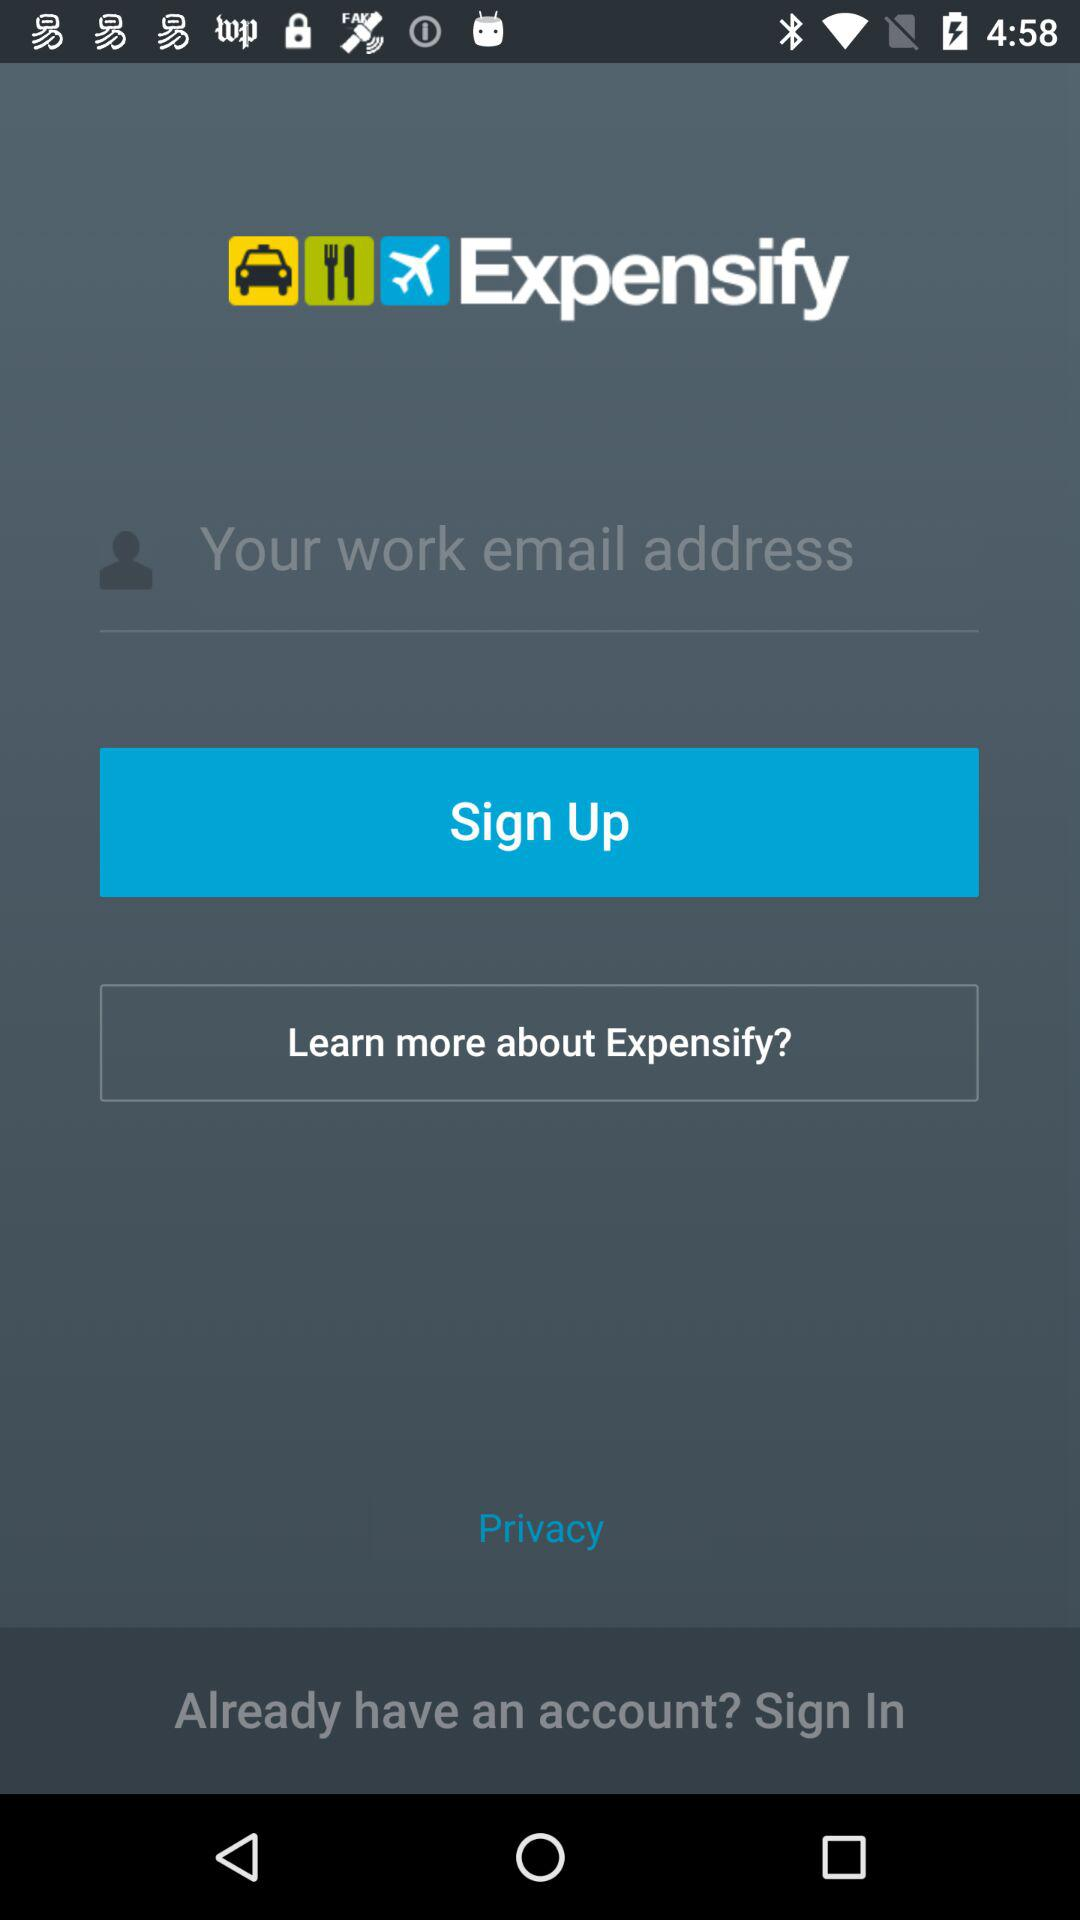Which email address is used for the account?
When the provided information is insufficient, respond with <no answer>. <no answer> 